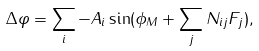Convert formula to latex. <formula><loc_0><loc_0><loc_500><loc_500>\Delta \varphi = \sum _ { i } - A _ { i } \sin ( \phi _ { M } + \sum _ { j } N _ { i j } F _ { j } ) ,</formula> 